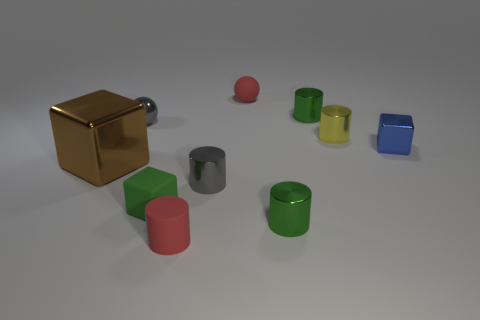Subtract 2 cylinders. How many cylinders are left? 3 Subtract all gray cylinders. How many cylinders are left? 4 Subtract all brown cylinders. Subtract all brown balls. How many cylinders are left? 5 Subtract all blocks. How many objects are left? 7 Subtract 0 yellow blocks. How many objects are left? 10 Subtract all red rubber balls. Subtract all tiny rubber spheres. How many objects are left? 8 Add 5 green matte objects. How many green matte objects are left? 6 Add 5 large purple cubes. How many large purple cubes exist? 5 